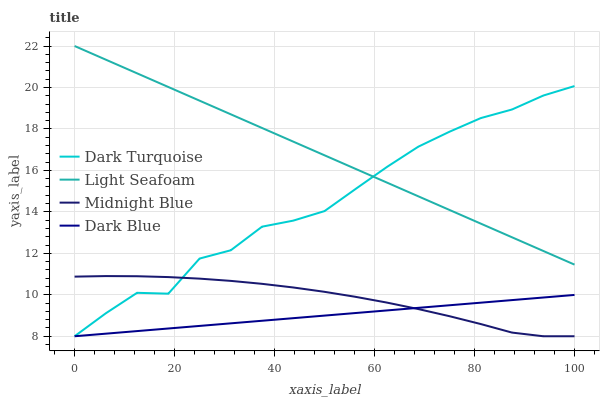Does Dark Blue have the minimum area under the curve?
Answer yes or no. Yes. Does Light Seafoam have the maximum area under the curve?
Answer yes or no. Yes. Does Midnight Blue have the minimum area under the curve?
Answer yes or no. No. Does Midnight Blue have the maximum area under the curve?
Answer yes or no. No. Is Dark Blue the smoothest?
Answer yes or no. Yes. Is Dark Turquoise the roughest?
Answer yes or no. Yes. Is Light Seafoam the smoothest?
Answer yes or no. No. Is Light Seafoam the roughest?
Answer yes or no. No. Does Dark Turquoise have the lowest value?
Answer yes or no. Yes. Does Light Seafoam have the lowest value?
Answer yes or no. No. Does Light Seafoam have the highest value?
Answer yes or no. Yes. Does Midnight Blue have the highest value?
Answer yes or no. No. Is Dark Blue less than Light Seafoam?
Answer yes or no. Yes. Is Light Seafoam greater than Midnight Blue?
Answer yes or no. Yes. Does Light Seafoam intersect Dark Turquoise?
Answer yes or no. Yes. Is Light Seafoam less than Dark Turquoise?
Answer yes or no. No. Is Light Seafoam greater than Dark Turquoise?
Answer yes or no. No. Does Dark Blue intersect Light Seafoam?
Answer yes or no. No. 